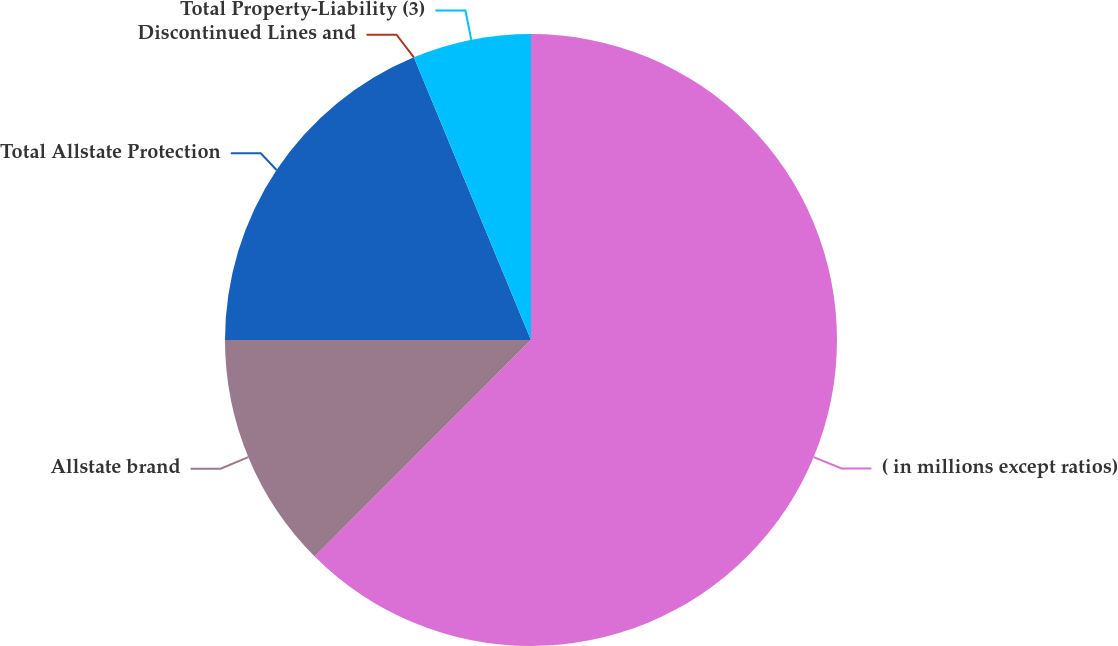Convert chart to OTSL. <chart><loc_0><loc_0><loc_500><loc_500><pie_chart><fcel>( in millions except ratios)<fcel>Allstate brand<fcel>Total Allstate Protection<fcel>Discontinued Lines and<fcel>Total Property-Liability (3)<nl><fcel>62.49%<fcel>12.5%<fcel>18.75%<fcel>0.0%<fcel>6.25%<nl></chart> 